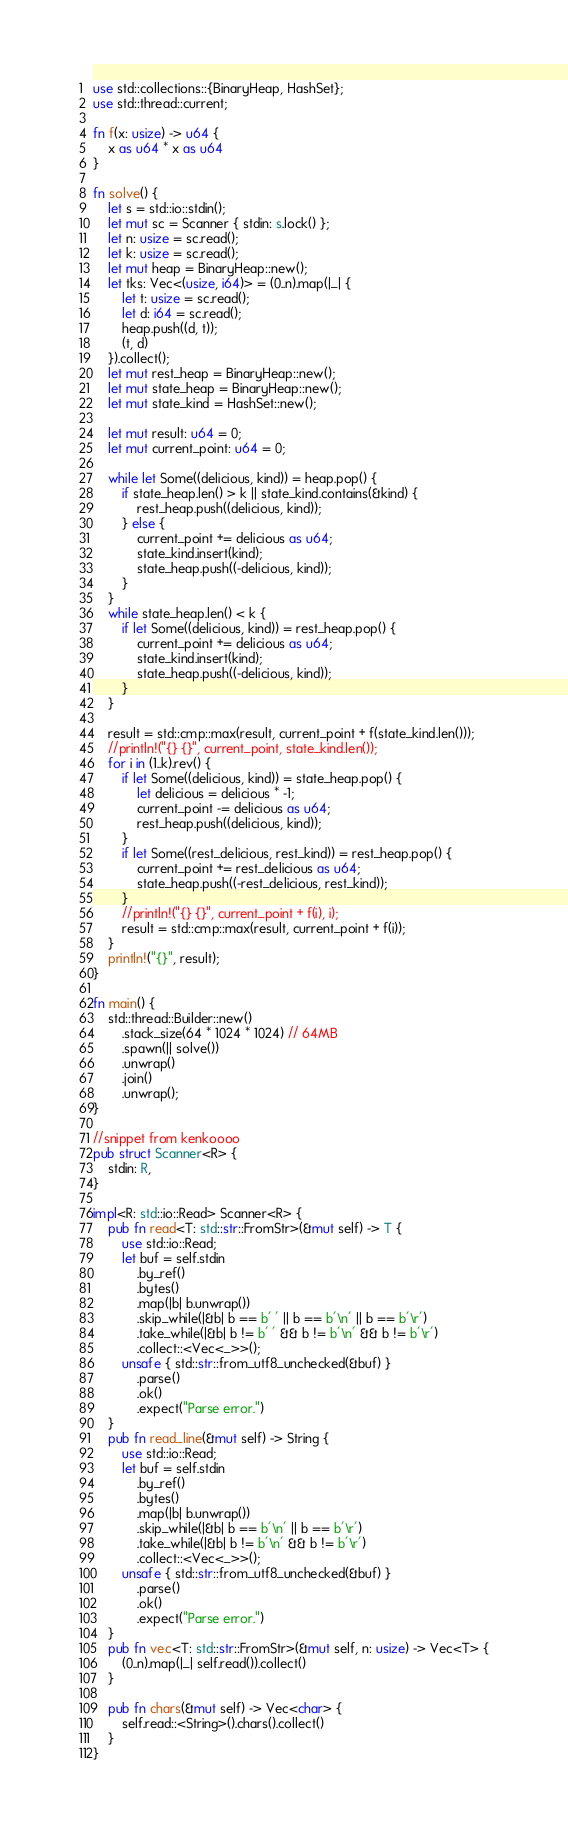Convert code to text. <code><loc_0><loc_0><loc_500><loc_500><_Rust_>use std::collections::{BinaryHeap, HashSet};
use std::thread::current;

fn f(x: usize) -> u64 {
    x as u64 * x as u64
}

fn solve() {
    let s = std::io::stdin();
    let mut sc = Scanner { stdin: s.lock() };
    let n: usize = sc.read();
    let k: usize = sc.read();
    let mut heap = BinaryHeap::new();
    let tks: Vec<(usize, i64)> = (0..n).map(|_| {
        let t: usize = sc.read();
        let d: i64 = sc.read();
        heap.push((d, t));
        (t, d)
    }).collect();
    let mut rest_heap = BinaryHeap::new();
    let mut state_heap = BinaryHeap::new();
    let mut state_kind = HashSet::new();

    let mut result: u64 = 0;
    let mut current_point: u64 = 0;

    while let Some((delicious, kind)) = heap.pop() {
        if state_heap.len() > k || state_kind.contains(&kind) {
            rest_heap.push((delicious, kind));
        } else {
            current_point += delicious as u64;
            state_kind.insert(kind);
            state_heap.push((-delicious, kind));
        }
    }
    while state_heap.len() < k {
        if let Some((delicious, kind)) = rest_heap.pop() {
            current_point += delicious as u64;
            state_kind.insert(kind);
            state_heap.push((-delicious, kind));
        }
    }

    result = std::cmp::max(result, current_point + f(state_kind.len()));
    //println!("{} {}", current_point, state_kind.len());
    for i in (1..k).rev() {
        if let Some((delicious, kind)) = state_heap.pop() {
            let delicious = delicious * -1;
            current_point -= delicious as u64;
            rest_heap.push((delicious, kind));
        }
        if let Some((rest_delicious, rest_kind)) = rest_heap.pop() {
            current_point += rest_delicious as u64;
            state_heap.push((-rest_delicious, rest_kind));
        }
        //println!("{} {}", current_point + f(i), i);
        result = std::cmp::max(result, current_point + f(i));
    }
    println!("{}", result);
}

fn main() {
    std::thread::Builder::new()
        .stack_size(64 * 1024 * 1024) // 64MB
        .spawn(|| solve())
        .unwrap()
        .join()
        .unwrap();
}

//snippet from kenkoooo
pub struct Scanner<R> {
    stdin: R,
}

impl<R: std::io::Read> Scanner<R> {
    pub fn read<T: std::str::FromStr>(&mut self) -> T {
        use std::io::Read;
        let buf = self.stdin
            .by_ref()
            .bytes()
            .map(|b| b.unwrap())
            .skip_while(|&b| b == b' ' || b == b'\n' || b == b'\r')
            .take_while(|&b| b != b' ' && b != b'\n' && b != b'\r')
            .collect::<Vec<_>>();
        unsafe { std::str::from_utf8_unchecked(&buf) }
            .parse()
            .ok()
            .expect("Parse error.")
    }
    pub fn read_line(&mut self) -> String {
        use std::io::Read;
        let buf = self.stdin
            .by_ref()
            .bytes()
            .map(|b| b.unwrap())
            .skip_while(|&b| b == b'\n' || b == b'\r')
            .take_while(|&b| b != b'\n' && b != b'\r')
            .collect::<Vec<_>>();
        unsafe { std::str::from_utf8_unchecked(&buf) }
            .parse()
            .ok()
            .expect("Parse error.")
    }
    pub fn vec<T: std::str::FromStr>(&mut self, n: usize) -> Vec<T> {
        (0..n).map(|_| self.read()).collect()
    }

    pub fn chars(&mut self) -> Vec<char> {
        self.read::<String>().chars().collect()
    }
}
</code> 